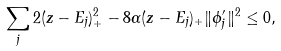Convert formula to latex. <formula><loc_0><loc_0><loc_500><loc_500>\sum _ { j } 2 ( z - E _ { j } ) _ { + } ^ { 2 } - 8 \alpha ( z - E _ { j } ) _ { + } \| \phi _ { j } ^ { \prime } \| ^ { 2 } \leq 0 ,</formula> 